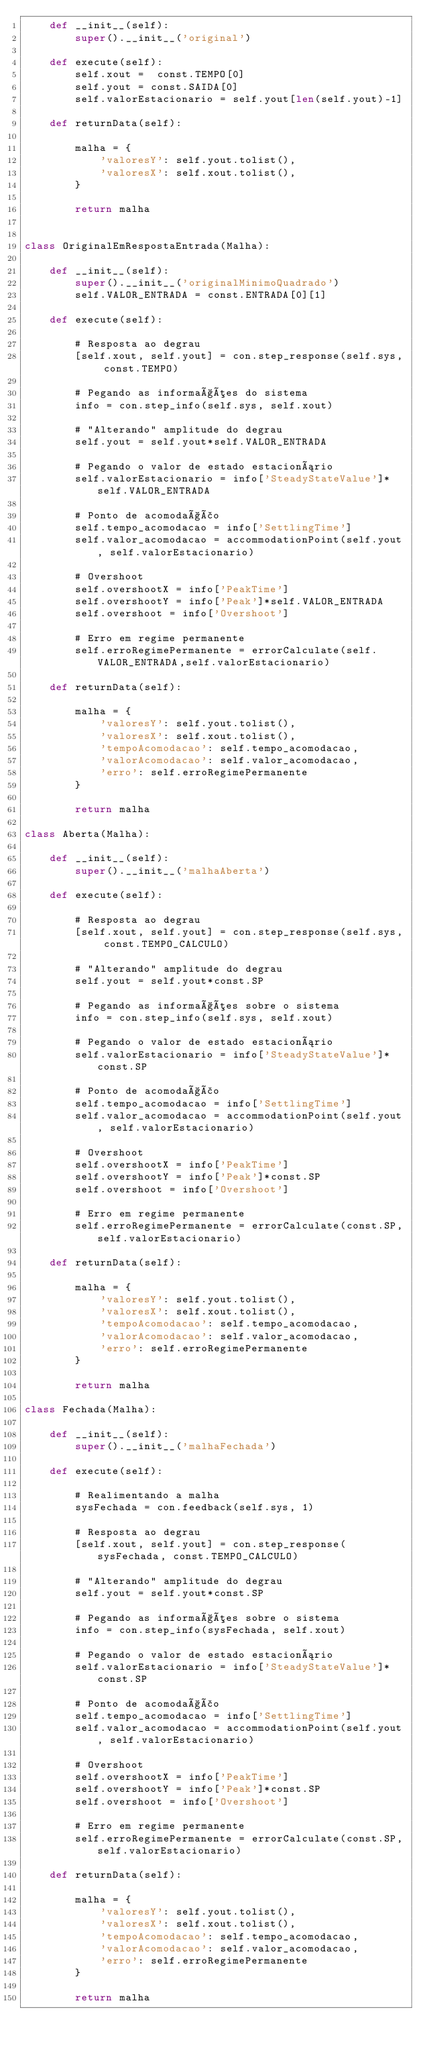<code> <loc_0><loc_0><loc_500><loc_500><_Python_>    def __init__(self):
        super().__init__('original')
    
    def execute(self):
        self.xout =  const.TEMPO[0]
        self.yout = const.SAIDA[0]
        self.valorEstacionario = self.yout[len(self.yout)-1]

    def returnData(self):

        malha = {
            'valoresY': self.yout.tolist(),
            'valoresX': self.xout.tolist(),
        }

        return malha
        

class OriginalEmRespostaEntrada(Malha):

    def __init__(self):
        super().__init__('originalMinimoQuadrado')
        self.VALOR_ENTRADA = const.ENTRADA[0][1]

    def execute(self):

        # Resposta ao degrau
        [self.xout, self.yout] = con.step_response(self.sys, const.TEMPO)

        # Pegando as informações do sistema
        info = con.step_info(self.sys, self.xout)

        # "Alterando" amplitude do degrau
        self.yout = self.yout*self.VALOR_ENTRADA

        # Pegando o valor de estado estacionário  
        self.valorEstacionario = info['SteadyStateValue']*self.VALOR_ENTRADA

        # Ponto de acomodação
        self.tempo_acomodacao = info['SettlingTime']
        self.valor_acomodacao = accommodationPoint(self.yout, self.valorEstacionario)

        # Overshoot
        self.overshootX = info['PeakTime']
        self.overshootY = info['Peak']*self.VALOR_ENTRADA
        self.overshoot = info['Overshoot']

        # Erro em regime permanente
        self.erroRegimePermanente = errorCalculate(self.VALOR_ENTRADA,self.valorEstacionario)

    def returnData(self):

        malha = {
            'valoresY': self.yout.tolist(),
            'valoresX': self.xout.tolist(),
            'tempoAcomodacao': self.tempo_acomodacao,
            'valorAcomodacao': self.valor_acomodacao,
            'erro': self.erroRegimePermanente
        }

        return malha

class Aberta(Malha):

    def __init__(self):
        super().__init__('malhaAberta')

    def execute(self):

        # Resposta ao degrau
        [self.xout, self.yout] = con.step_response(self.sys, const.TEMPO_CALCULO)

        # "Alterando" amplitude do degrau
        self.yout = self.yout*const.SP

        # Pegando as informações sobre o sistema 
        info = con.step_info(self.sys, self.xout)
        
        # Pegando o valor de estado estacionário  
        self.valorEstacionario = info['SteadyStateValue']*const.SP

        # Ponto de acomodação
        self.tempo_acomodacao = info['SettlingTime']
        self.valor_acomodacao = accommodationPoint(self.yout, self.valorEstacionario)

        # Overshoot
        self.overshootX = info['PeakTime']
        self.overshootY = info['Peak']*const.SP
        self.overshoot = info['Overshoot']

        # Erro em regime permanente
        self.erroRegimePermanente = errorCalculate(const.SP,self.valorEstacionario)

    def returnData(self):

        malha = {
            'valoresY': self.yout.tolist(),
            'valoresX': self.xout.tolist(),
            'tempoAcomodacao': self.tempo_acomodacao,
            'valorAcomodacao': self.valor_acomodacao,
            'erro': self.erroRegimePermanente
        }

        return malha
             
class Fechada(Malha):

    def __init__(self):
        super().__init__('malhaFechada')
    
    def execute(self):

        # Realimentando a malha
        sysFechada = con.feedback(self.sys, 1)
        
        # Resposta ao degrau
        [self.xout, self.yout] = con.step_response(sysFechada, const.TEMPO_CALCULO)

        # "Alterando" amplitude do degrau
        self.yout = self.yout*const.SP

        # Pegando as informações sobre o sistema
        info = con.step_info(sysFechada, self.xout)
        
        # Pegando o valor de estado estacionário  
        self.valorEstacionario = info['SteadyStateValue']*const.SP

        # Ponto de acomodação
        self.tempo_acomodacao = info['SettlingTime']
        self.valor_acomodacao = accommodationPoint(self.yout, self.valorEstacionario)

        # Overshoot
        self.overshootX = info['PeakTime']
        self.overshootY = info['Peak']*const.SP
        self.overshoot = info['Overshoot']

        # Erro em regime permanente
        self.erroRegimePermanente = errorCalculate(const.SP,self.valorEstacionario)

    def returnData(self):

        malha = {
            'valoresY': self.yout.tolist(),
            'valoresX': self.xout.tolist(),
            'tempoAcomodacao': self.tempo_acomodacao,
            'valorAcomodacao': self.valor_acomodacao,
            'erro': self.erroRegimePermanente
        }

        return malha
</code> 